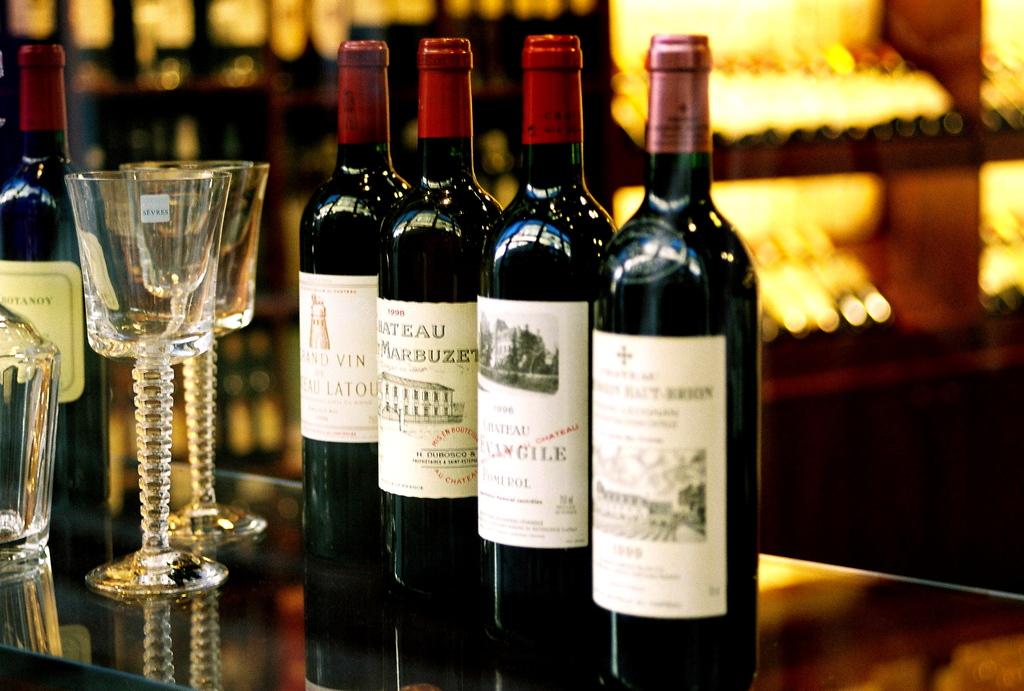What is the name of the third wine from the left?
Your answer should be very brief. Chateau marbuzet. 